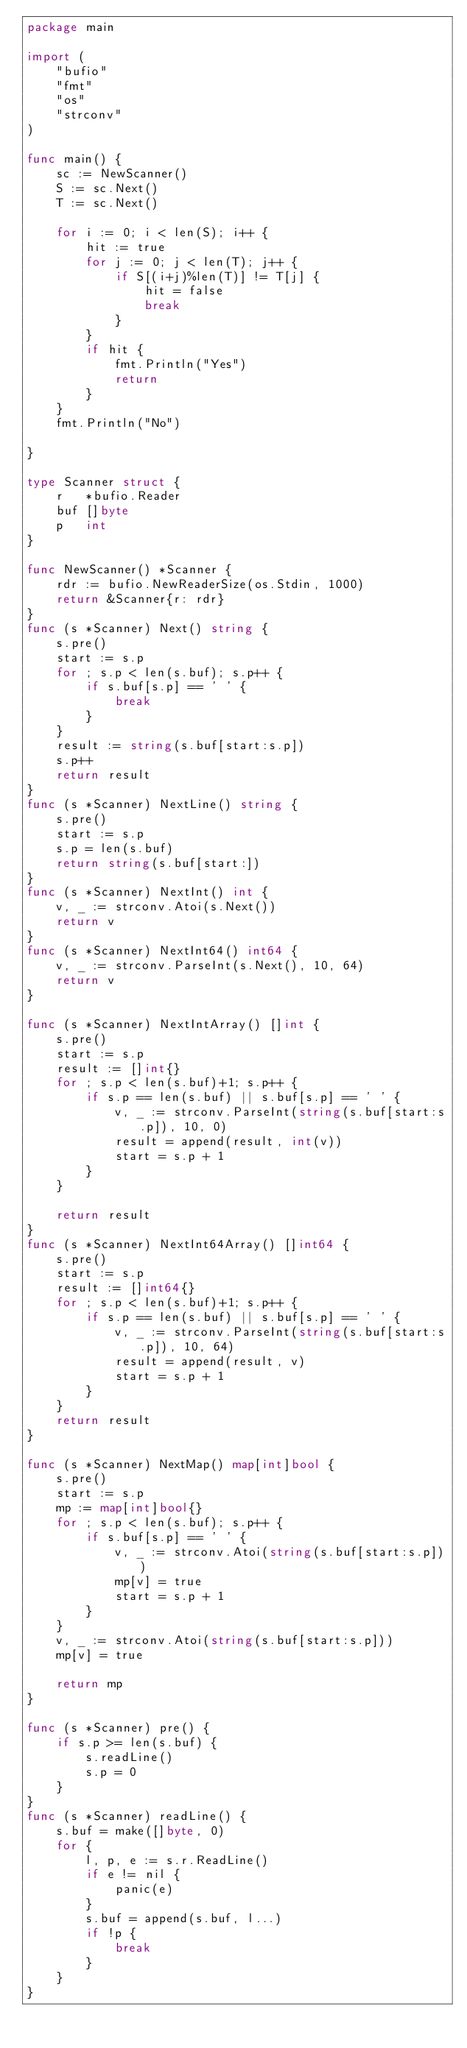Convert code to text. <code><loc_0><loc_0><loc_500><loc_500><_Go_>package main

import (
	"bufio"
	"fmt"
	"os"
	"strconv"
)

func main() {
	sc := NewScanner()
	S := sc.Next()
	T := sc.Next()

	for i := 0; i < len(S); i++ {
		hit := true
		for j := 0; j < len(T); j++ {
			if S[(i+j)%len(T)] != T[j] {
				hit = false
				break
			}
		}
		if hit {
			fmt.Println("Yes")
			return
		}
	}
	fmt.Println("No")

}

type Scanner struct {
	r   *bufio.Reader
	buf []byte
	p   int
}

func NewScanner() *Scanner {
	rdr := bufio.NewReaderSize(os.Stdin, 1000)
	return &Scanner{r: rdr}
}
func (s *Scanner) Next() string {
	s.pre()
	start := s.p
	for ; s.p < len(s.buf); s.p++ {
		if s.buf[s.p] == ' ' {
			break
		}
	}
	result := string(s.buf[start:s.p])
	s.p++
	return result
}
func (s *Scanner) NextLine() string {
	s.pre()
	start := s.p
	s.p = len(s.buf)
	return string(s.buf[start:])
}
func (s *Scanner) NextInt() int {
	v, _ := strconv.Atoi(s.Next())
	return v
}
func (s *Scanner) NextInt64() int64 {
	v, _ := strconv.ParseInt(s.Next(), 10, 64)
	return v
}

func (s *Scanner) NextIntArray() []int {
	s.pre()
	start := s.p
	result := []int{}
	for ; s.p < len(s.buf)+1; s.p++ {
		if s.p == len(s.buf) || s.buf[s.p] == ' ' {
			v, _ := strconv.ParseInt(string(s.buf[start:s.p]), 10, 0)
			result = append(result, int(v))
			start = s.p + 1
		}
	}

	return result
}
func (s *Scanner) NextInt64Array() []int64 {
	s.pre()
	start := s.p
	result := []int64{}
	for ; s.p < len(s.buf)+1; s.p++ {
		if s.p == len(s.buf) || s.buf[s.p] == ' ' {
			v, _ := strconv.ParseInt(string(s.buf[start:s.p]), 10, 64)
			result = append(result, v)
			start = s.p + 1
		}
	}
	return result
}

func (s *Scanner) NextMap() map[int]bool {
	s.pre()
	start := s.p
	mp := map[int]bool{}
	for ; s.p < len(s.buf); s.p++ {
		if s.buf[s.p] == ' ' {
			v, _ := strconv.Atoi(string(s.buf[start:s.p]))
			mp[v] = true
			start = s.p + 1
		}
	}
	v, _ := strconv.Atoi(string(s.buf[start:s.p]))
	mp[v] = true

	return mp
}

func (s *Scanner) pre() {
	if s.p >= len(s.buf) {
		s.readLine()
		s.p = 0
	}
}
func (s *Scanner) readLine() {
	s.buf = make([]byte, 0)
	for {
		l, p, e := s.r.ReadLine()
		if e != nil {
			panic(e)
		}
		s.buf = append(s.buf, l...)
		if !p {
			break
		}
	}
}
</code> 